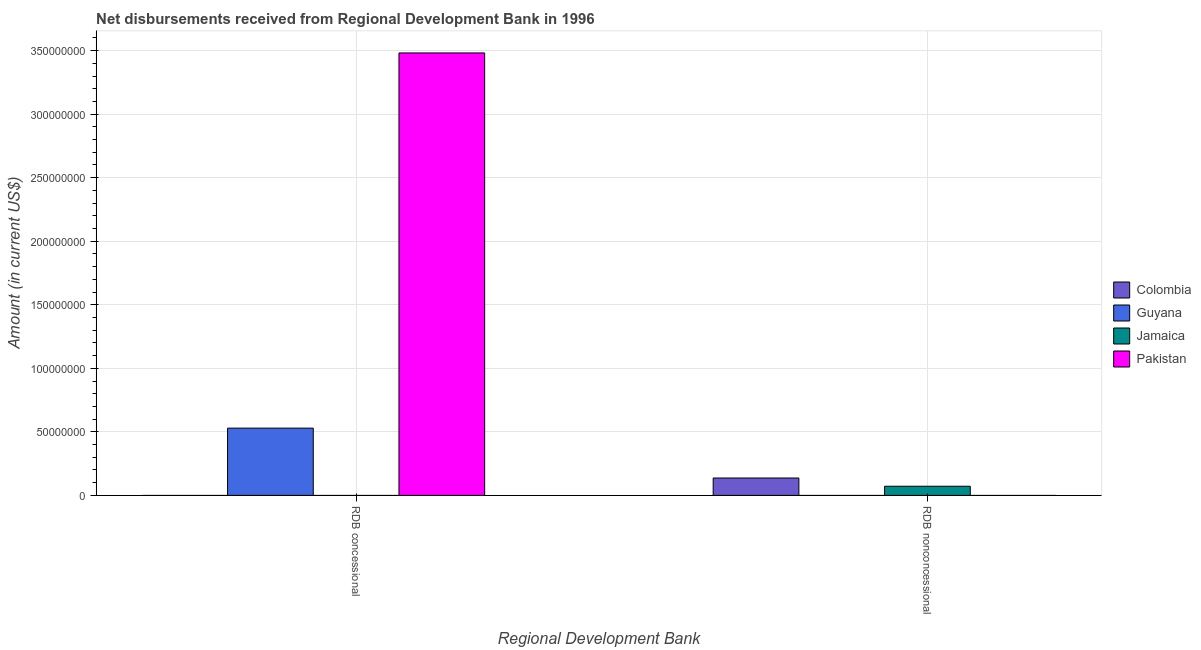How many different coloured bars are there?
Offer a terse response. 4. How many groups of bars are there?
Provide a succinct answer. 2. Are the number of bars per tick equal to the number of legend labels?
Provide a succinct answer. No. How many bars are there on the 2nd tick from the right?
Keep it short and to the point. 2. What is the label of the 2nd group of bars from the left?
Your answer should be compact. RDB nonconcessional. What is the net concessional disbursements from rdb in Guyana?
Your response must be concise. 5.29e+07. Across all countries, what is the maximum net concessional disbursements from rdb?
Offer a very short reply. 3.48e+08. In which country was the net non concessional disbursements from rdb maximum?
Provide a succinct answer. Colombia. What is the total net non concessional disbursements from rdb in the graph?
Provide a short and direct response. 2.09e+07. What is the difference between the net concessional disbursements from rdb in Guyana and that in Pakistan?
Your response must be concise. -2.95e+08. What is the difference between the net concessional disbursements from rdb in Jamaica and the net non concessional disbursements from rdb in Guyana?
Offer a terse response. 0. What is the average net non concessional disbursements from rdb per country?
Ensure brevity in your answer.  5.22e+06. What is the ratio of the net concessional disbursements from rdb in Pakistan to that in Guyana?
Make the answer very short. 6.58. Is the net concessional disbursements from rdb in Pakistan less than that in Guyana?
Keep it short and to the point. No. In how many countries, is the net non concessional disbursements from rdb greater than the average net non concessional disbursements from rdb taken over all countries?
Your answer should be compact. 2. How many bars are there?
Give a very brief answer. 4. How many countries are there in the graph?
Provide a short and direct response. 4. What is the difference between two consecutive major ticks on the Y-axis?
Provide a succinct answer. 5.00e+07. Are the values on the major ticks of Y-axis written in scientific E-notation?
Your answer should be compact. No. Does the graph contain any zero values?
Provide a succinct answer. Yes. How are the legend labels stacked?
Your answer should be very brief. Vertical. What is the title of the graph?
Make the answer very short. Net disbursements received from Regional Development Bank in 1996. What is the label or title of the X-axis?
Ensure brevity in your answer.  Regional Development Bank. What is the label or title of the Y-axis?
Offer a very short reply. Amount (in current US$). What is the Amount (in current US$) of Colombia in RDB concessional?
Ensure brevity in your answer.  0. What is the Amount (in current US$) of Guyana in RDB concessional?
Your response must be concise. 5.29e+07. What is the Amount (in current US$) of Jamaica in RDB concessional?
Your answer should be very brief. 0. What is the Amount (in current US$) of Pakistan in RDB concessional?
Make the answer very short. 3.48e+08. What is the Amount (in current US$) of Colombia in RDB nonconcessional?
Your answer should be compact. 1.37e+07. What is the Amount (in current US$) of Guyana in RDB nonconcessional?
Your answer should be very brief. 0. What is the Amount (in current US$) in Jamaica in RDB nonconcessional?
Provide a short and direct response. 7.20e+06. Across all Regional Development Bank, what is the maximum Amount (in current US$) of Colombia?
Offer a terse response. 1.37e+07. Across all Regional Development Bank, what is the maximum Amount (in current US$) of Guyana?
Ensure brevity in your answer.  5.29e+07. Across all Regional Development Bank, what is the maximum Amount (in current US$) in Jamaica?
Your answer should be compact. 7.20e+06. Across all Regional Development Bank, what is the maximum Amount (in current US$) in Pakistan?
Provide a short and direct response. 3.48e+08. Across all Regional Development Bank, what is the minimum Amount (in current US$) of Colombia?
Keep it short and to the point. 0. Across all Regional Development Bank, what is the minimum Amount (in current US$) in Guyana?
Offer a very short reply. 0. Across all Regional Development Bank, what is the minimum Amount (in current US$) in Jamaica?
Provide a succinct answer. 0. What is the total Amount (in current US$) of Colombia in the graph?
Make the answer very short. 1.37e+07. What is the total Amount (in current US$) of Guyana in the graph?
Give a very brief answer. 5.29e+07. What is the total Amount (in current US$) in Jamaica in the graph?
Provide a short and direct response. 7.20e+06. What is the total Amount (in current US$) of Pakistan in the graph?
Make the answer very short. 3.48e+08. What is the difference between the Amount (in current US$) in Guyana in RDB concessional and the Amount (in current US$) in Jamaica in RDB nonconcessional?
Your answer should be compact. 4.57e+07. What is the average Amount (in current US$) of Colombia per Regional Development Bank?
Make the answer very short. 6.84e+06. What is the average Amount (in current US$) in Guyana per Regional Development Bank?
Ensure brevity in your answer.  2.65e+07. What is the average Amount (in current US$) of Jamaica per Regional Development Bank?
Provide a succinct answer. 3.60e+06. What is the average Amount (in current US$) of Pakistan per Regional Development Bank?
Offer a very short reply. 1.74e+08. What is the difference between the Amount (in current US$) in Guyana and Amount (in current US$) in Pakistan in RDB concessional?
Your answer should be compact. -2.95e+08. What is the difference between the Amount (in current US$) of Colombia and Amount (in current US$) of Jamaica in RDB nonconcessional?
Make the answer very short. 6.48e+06. What is the difference between the highest and the lowest Amount (in current US$) in Colombia?
Provide a succinct answer. 1.37e+07. What is the difference between the highest and the lowest Amount (in current US$) of Guyana?
Make the answer very short. 5.29e+07. What is the difference between the highest and the lowest Amount (in current US$) in Jamaica?
Keep it short and to the point. 7.20e+06. What is the difference between the highest and the lowest Amount (in current US$) of Pakistan?
Offer a terse response. 3.48e+08. 